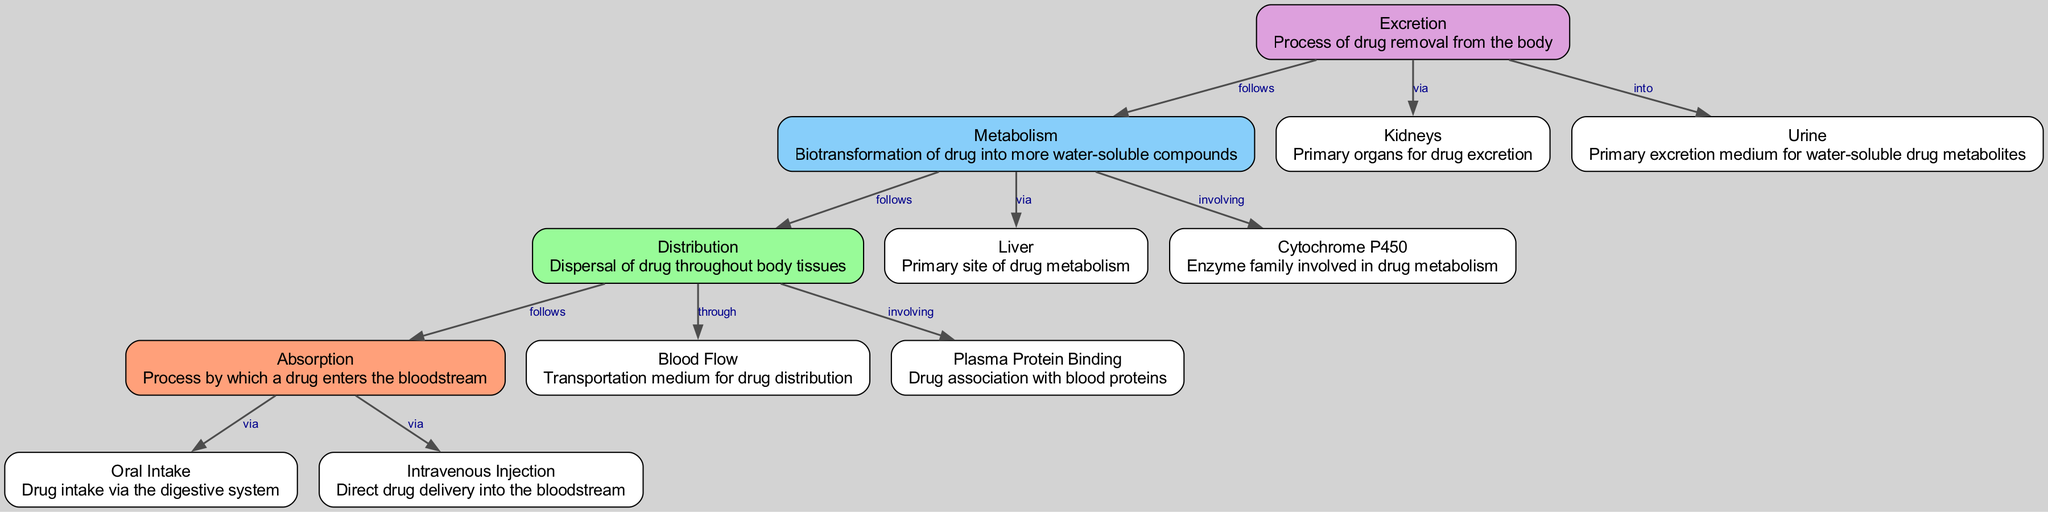What is the primary site of drug metabolism? The diagram indicates the "Liver" as the primary organ responsible for drug metabolism, as stated in the node description.
Answer: Liver How many nodes are present in the diagram? By counting the nodes listed in the data, there are 12 distinct nodes.
Answer: 12 What follows distribution in the pharmacokinetics process? According to the diagram, "metabolism" follows distribution, as indicated by the edge connecting these two nodes.
Answer: Metabolism What is the average medium for the excretion of drug metabolites? The diagram specifies "Urine" as the primary excretion medium for water-soluble drug metabolites, as described in the relevant node.
Answer: Urine What type of drug intake does absorption occur via? The diagram shows that absorption occurs via "Oral Intake" and "Intravenous Injection," with both types indicated as inputs for the absorption process.
Answer: Oral Intake, Intravenous Injection What connects distribution to blood flow? The relationship between distribution and blood flow is established by the label "through," indicating how the drug is dispersed via blood flow in the body.
Answer: through Which enzymes are involved in drug metabolism according to the diagram? The enzyme family specified in the diagram that plays a critical role in drug metabolism is "Cytochrome P450," as indicated in the relevant node description.
Answer: Cytochrome P450 Which organs are primarily responsible for drug excretion? The diagram mentions "Kidneys" as the primary organs for the process of drug excretion, as outlined in the node description.
Answer: Kidneys 